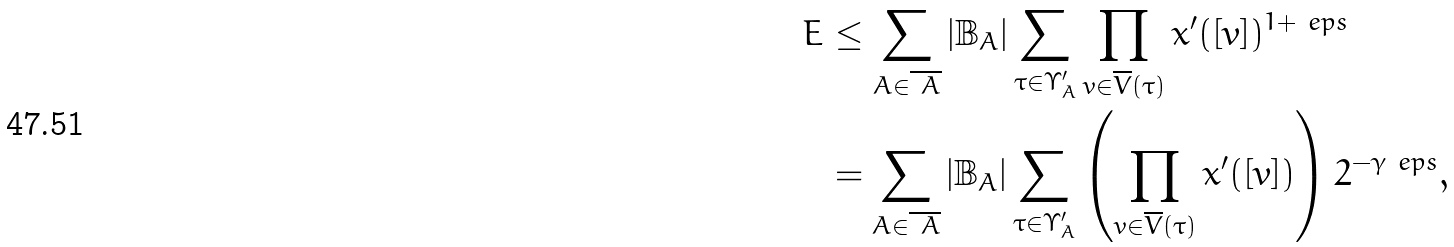<formula> <loc_0><loc_0><loc_500><loc_500>E & \leq \sum _ { A \in \overline { \ A } } | \mathbb { B } _ { A } | \sum _ { \tau \in \Upsilon _ { A } ^ { \prime } } \prod _ { v \in \overline { V } ( \tau ) } x ^ { \prime } ( [ v ] ) ^ { 1 + \ e p s } \\ & = \sum _ { A \in \overline { \ A } } | \mathbb { B } _ { A } | \sum _ { \tau \in \Upsilon _ { A } ^ { \prime } } \left ( \prod _ { v \in \overline { V } ( \tau ) } x ^ { \prime } ( [ v ] ) \right ) 2 ^ { - \gamma \ e p s } , \\</formula> 